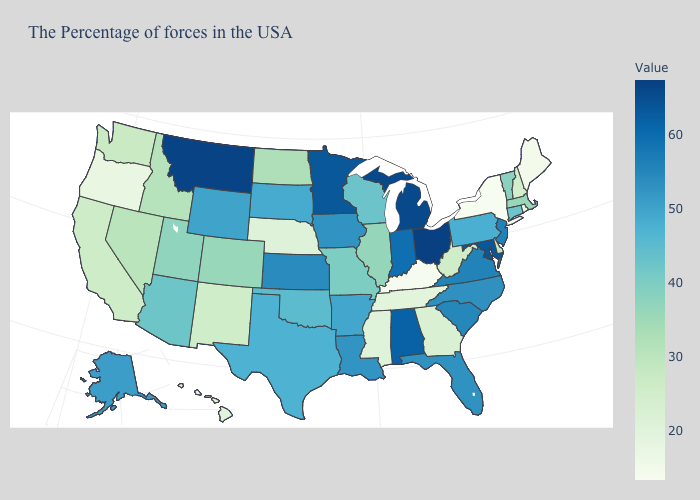Which states hav the highest value in the South?
Keep it brief. Maryland. Does Massachusetts have the lowest value in the USA?
Give a very brief answer. No. Does Alabama have the highest value in the South?
Quick response, please. No. Does Oregon have the lowest value in the West?
Concise answer only. Yes. 